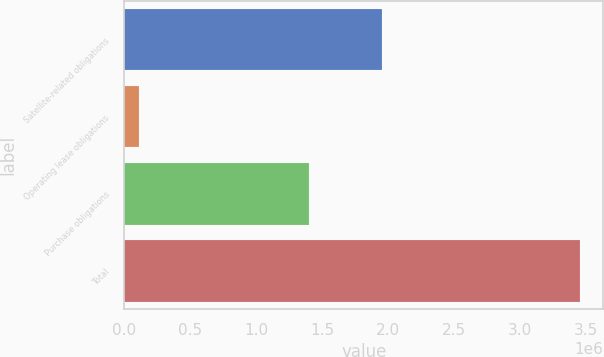Convert chart. <chart><loc_0><loc_0><loc_500><loc_500><bar_chart><fcel>Satellite-related obligations<fcel>Operating lease obligations<fcel>Purchase obligations<fcel>Total<nl><fcel>1.94849e+06<fcel>109223<fcel>1.39799e+06<fcel>3.4557e+06<nl></chart> 